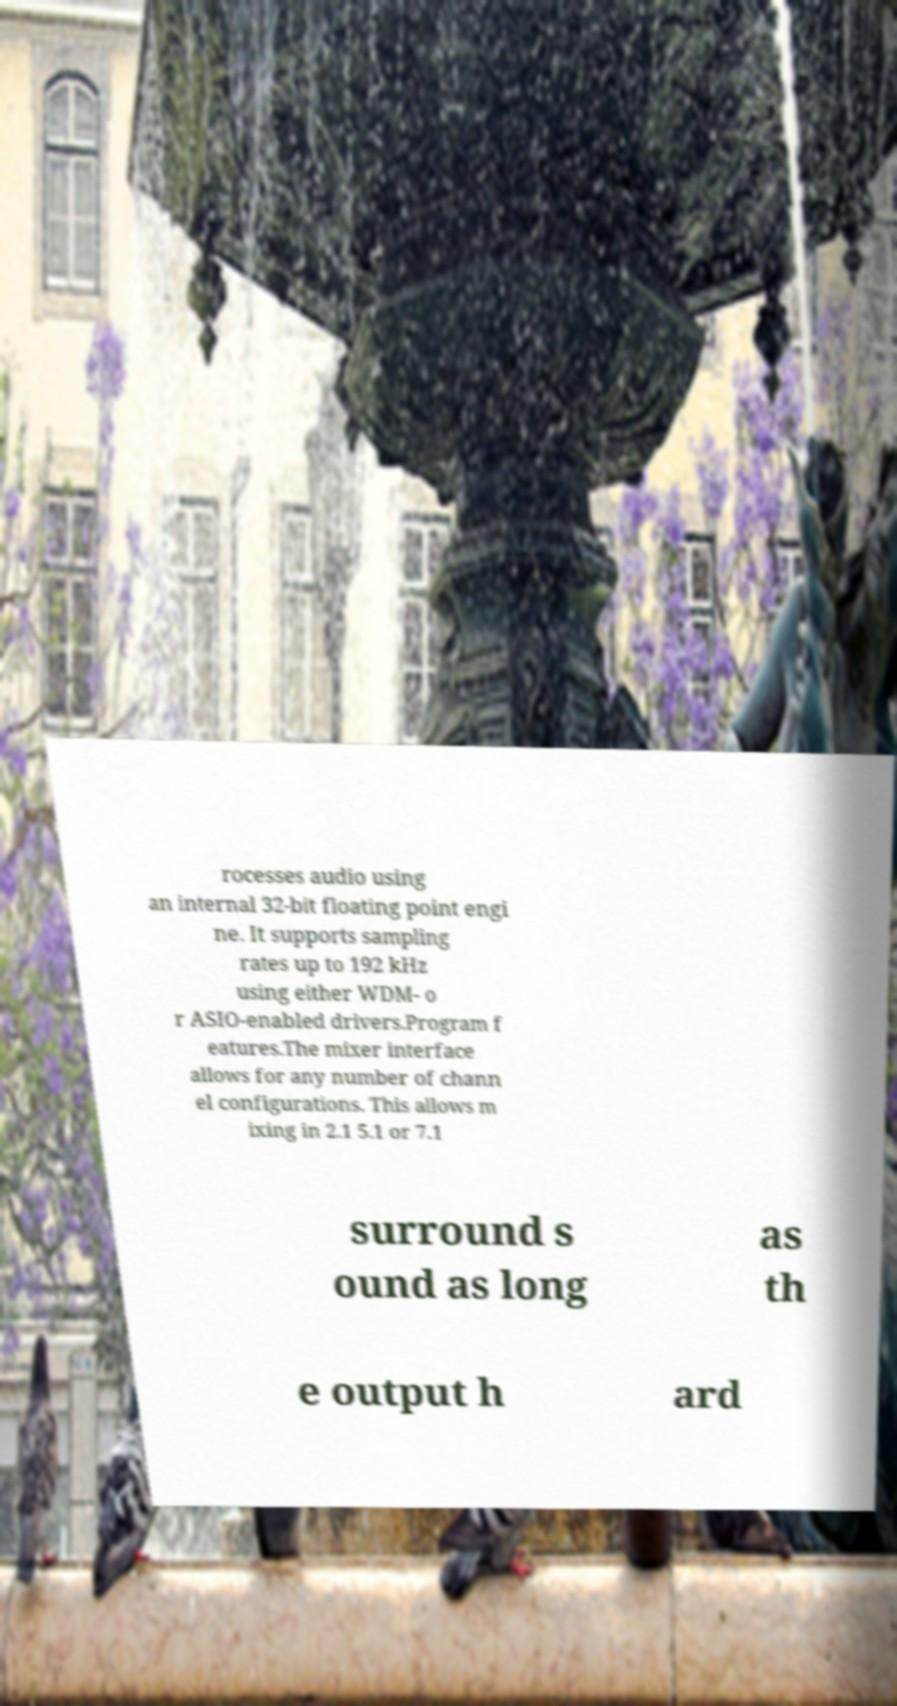There's text embedded in this image that I need extracted. Can you transcribe it verbatim? rocesses audio using an internal 32-bit floating point engi ne. It supports sampling rates up to 192 kHz using either WDM- o r ASIO-enabled drivers.Program f eatures.The mixer interface allows for any number of chann el configurations. This allows m ixing in 2.1 5.1 or 7.1 surround s ound as long as th e output h ard 